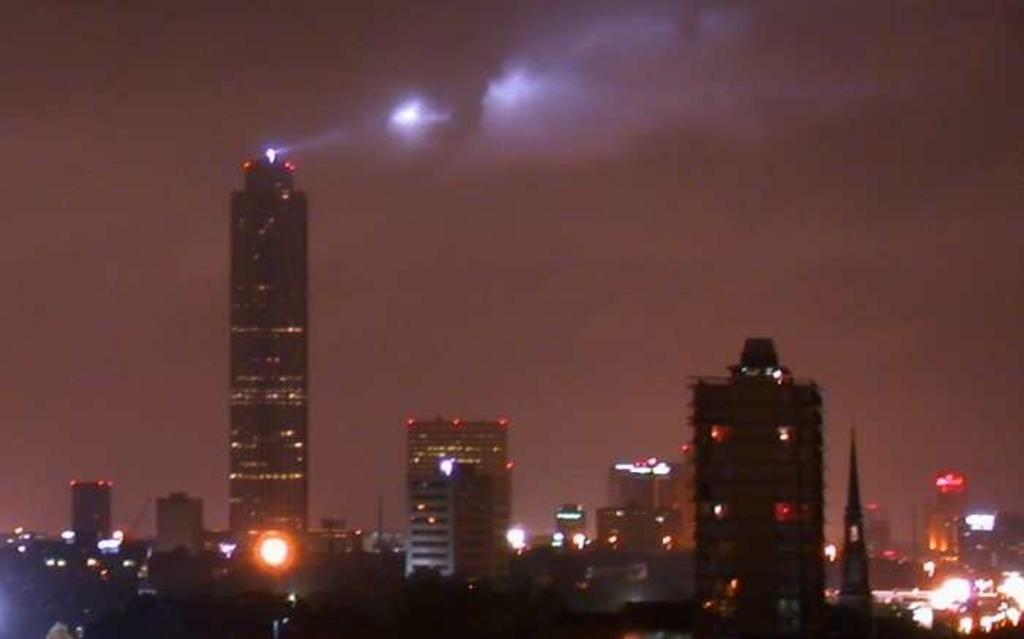Could you give a brief overview of what you see in this image? This is a night view of a city. In this image there are buildings and a sky. 